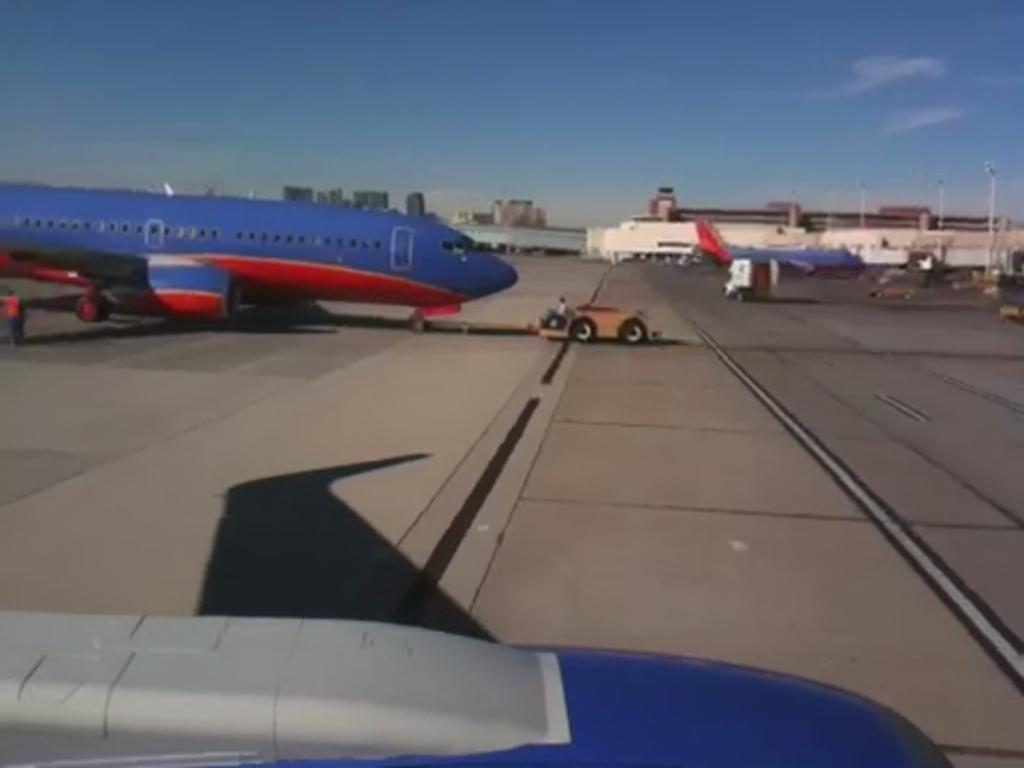What type of location is depicted in the image? The image depicts an airport. Can you describe the airplane in the image? There is a blue-colored airplane on the left side of the image. What color is the sky in the image? The sky is blue in the image. How many wrens can be seen perched on the hook in the image? There are no wrens or hooks present in the image. What type of plate is being used by the passengers in the image? There is no plate visible in the image, as it depicts an airport and an airplane. 